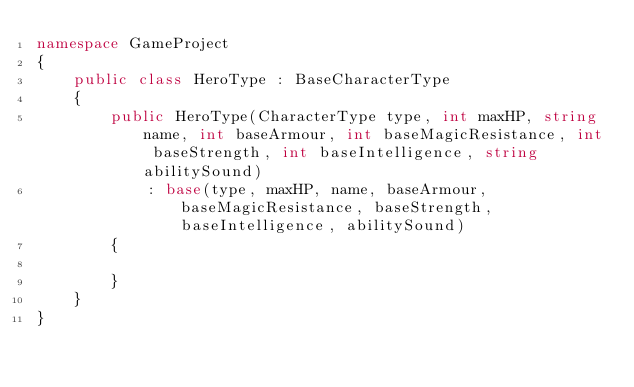Convert code to text. <code><loc_0><loc_0><loc_500><loc_500><_C#_>namespace GameProject
{
    public class HeroType : BaseCharacterType
    {
        public HeroType(CharacterType type, int maxHP, string name, int baseArmour, int baseMagicResistance, int baseStrength, int baseIntelligence, string abilitySound)
            : base(type, maxHP, name, baseArmour, baseMagicResistance, baseStrength, baseIntelligence, abilitySound)
        {

        }
    }
}</code> 